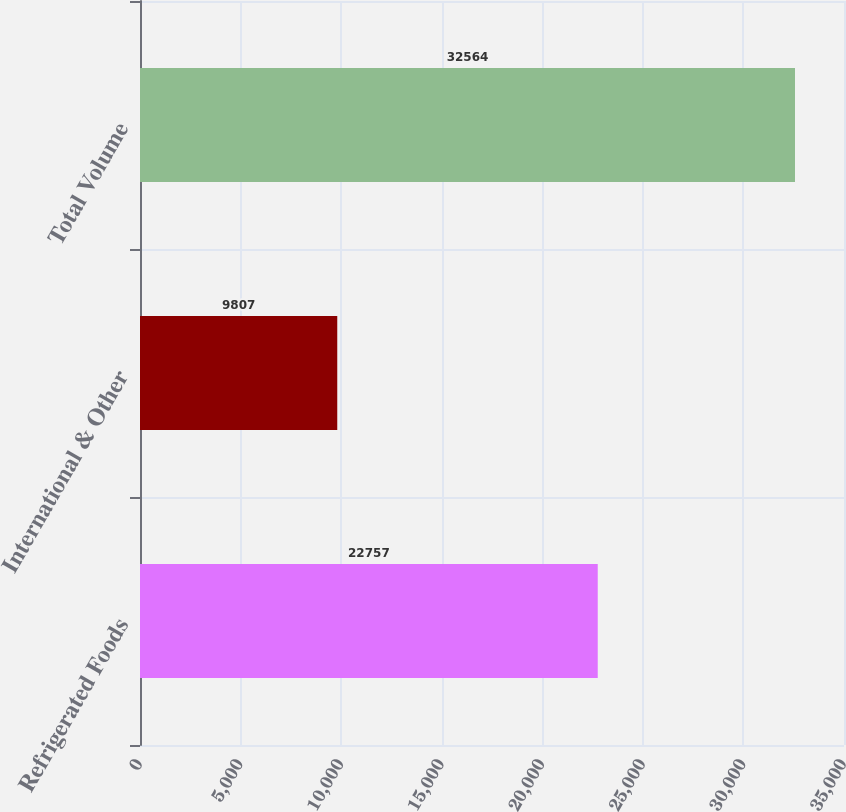<chart> <loc_0><loc_0><loc_500><loc_500><bar_chart><fcel>Refrigerated Foods<fcel>International & Other<fcel>Total Volume<nl><fcel>22757<fcel>9807<fcel>32564<nl></chart> 